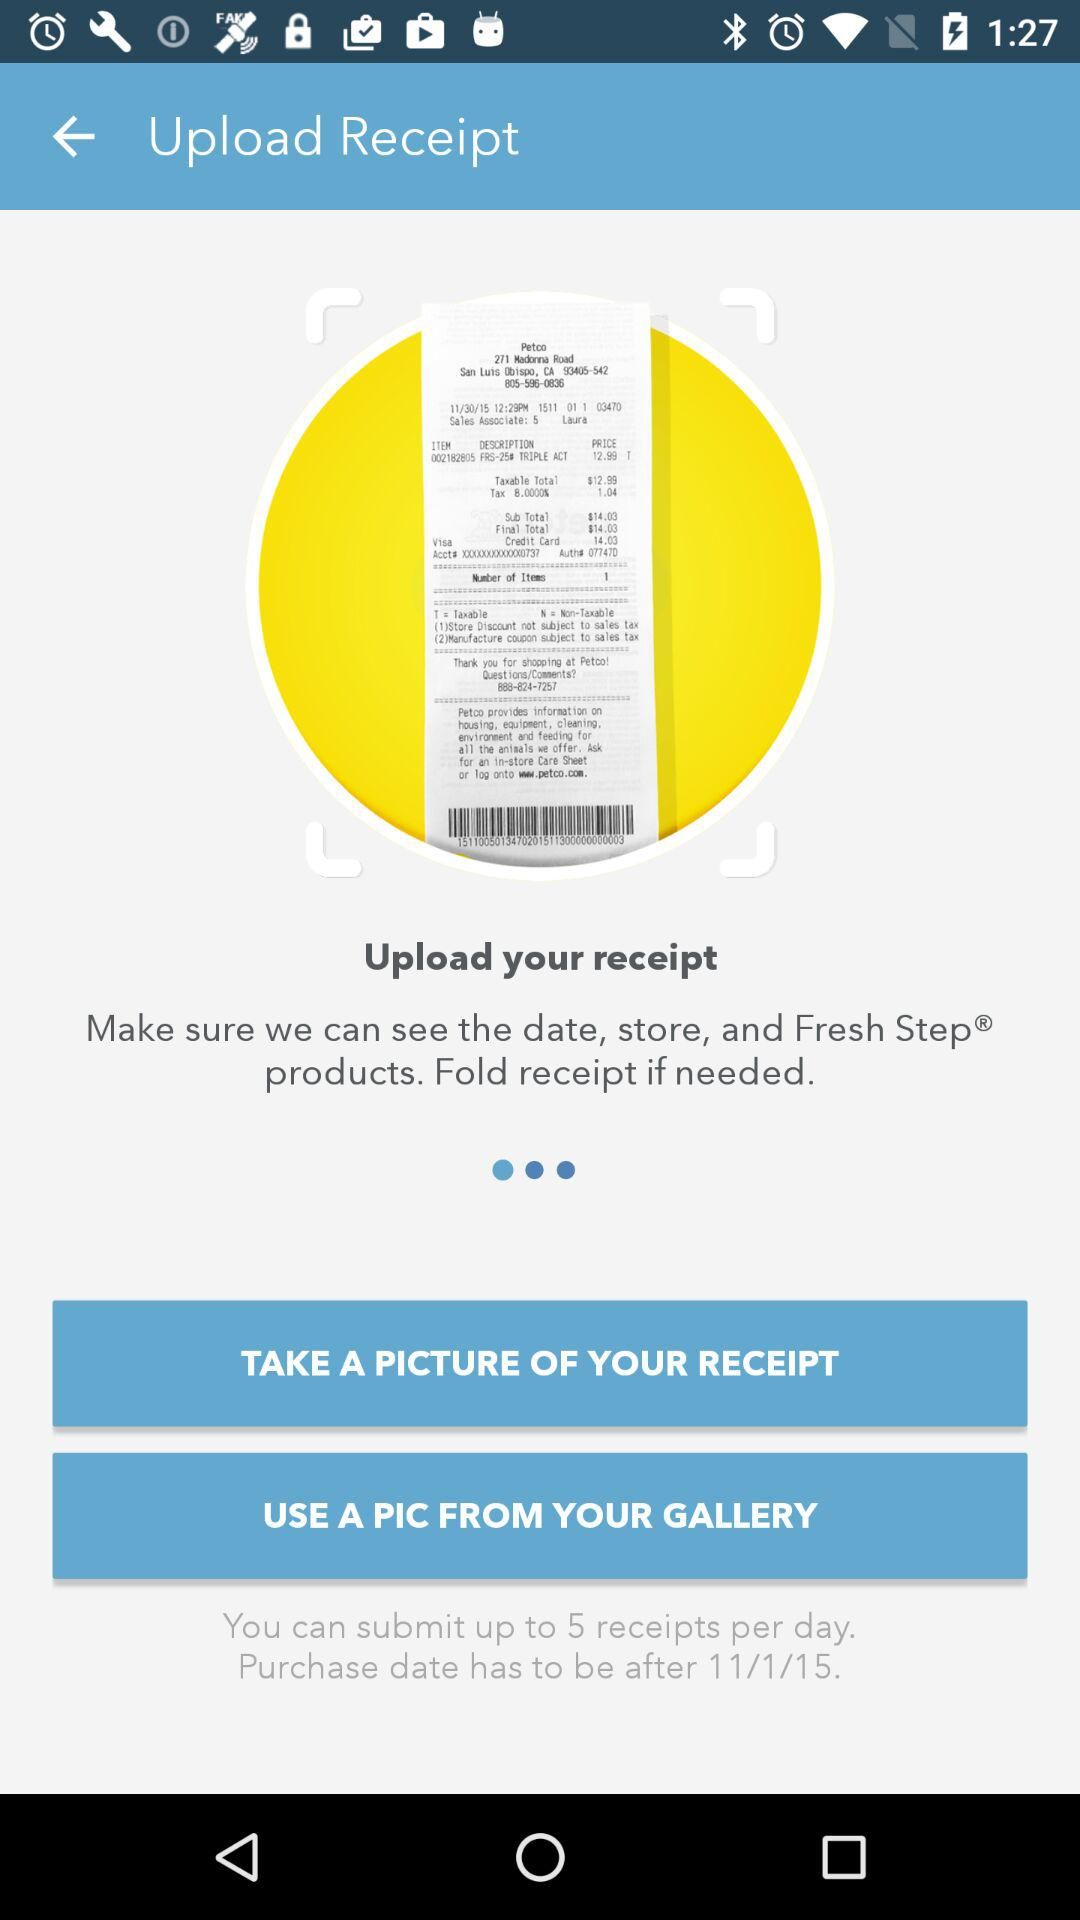How many receipts can I submit per day?
Answer the question using a single word or phrase. 5 